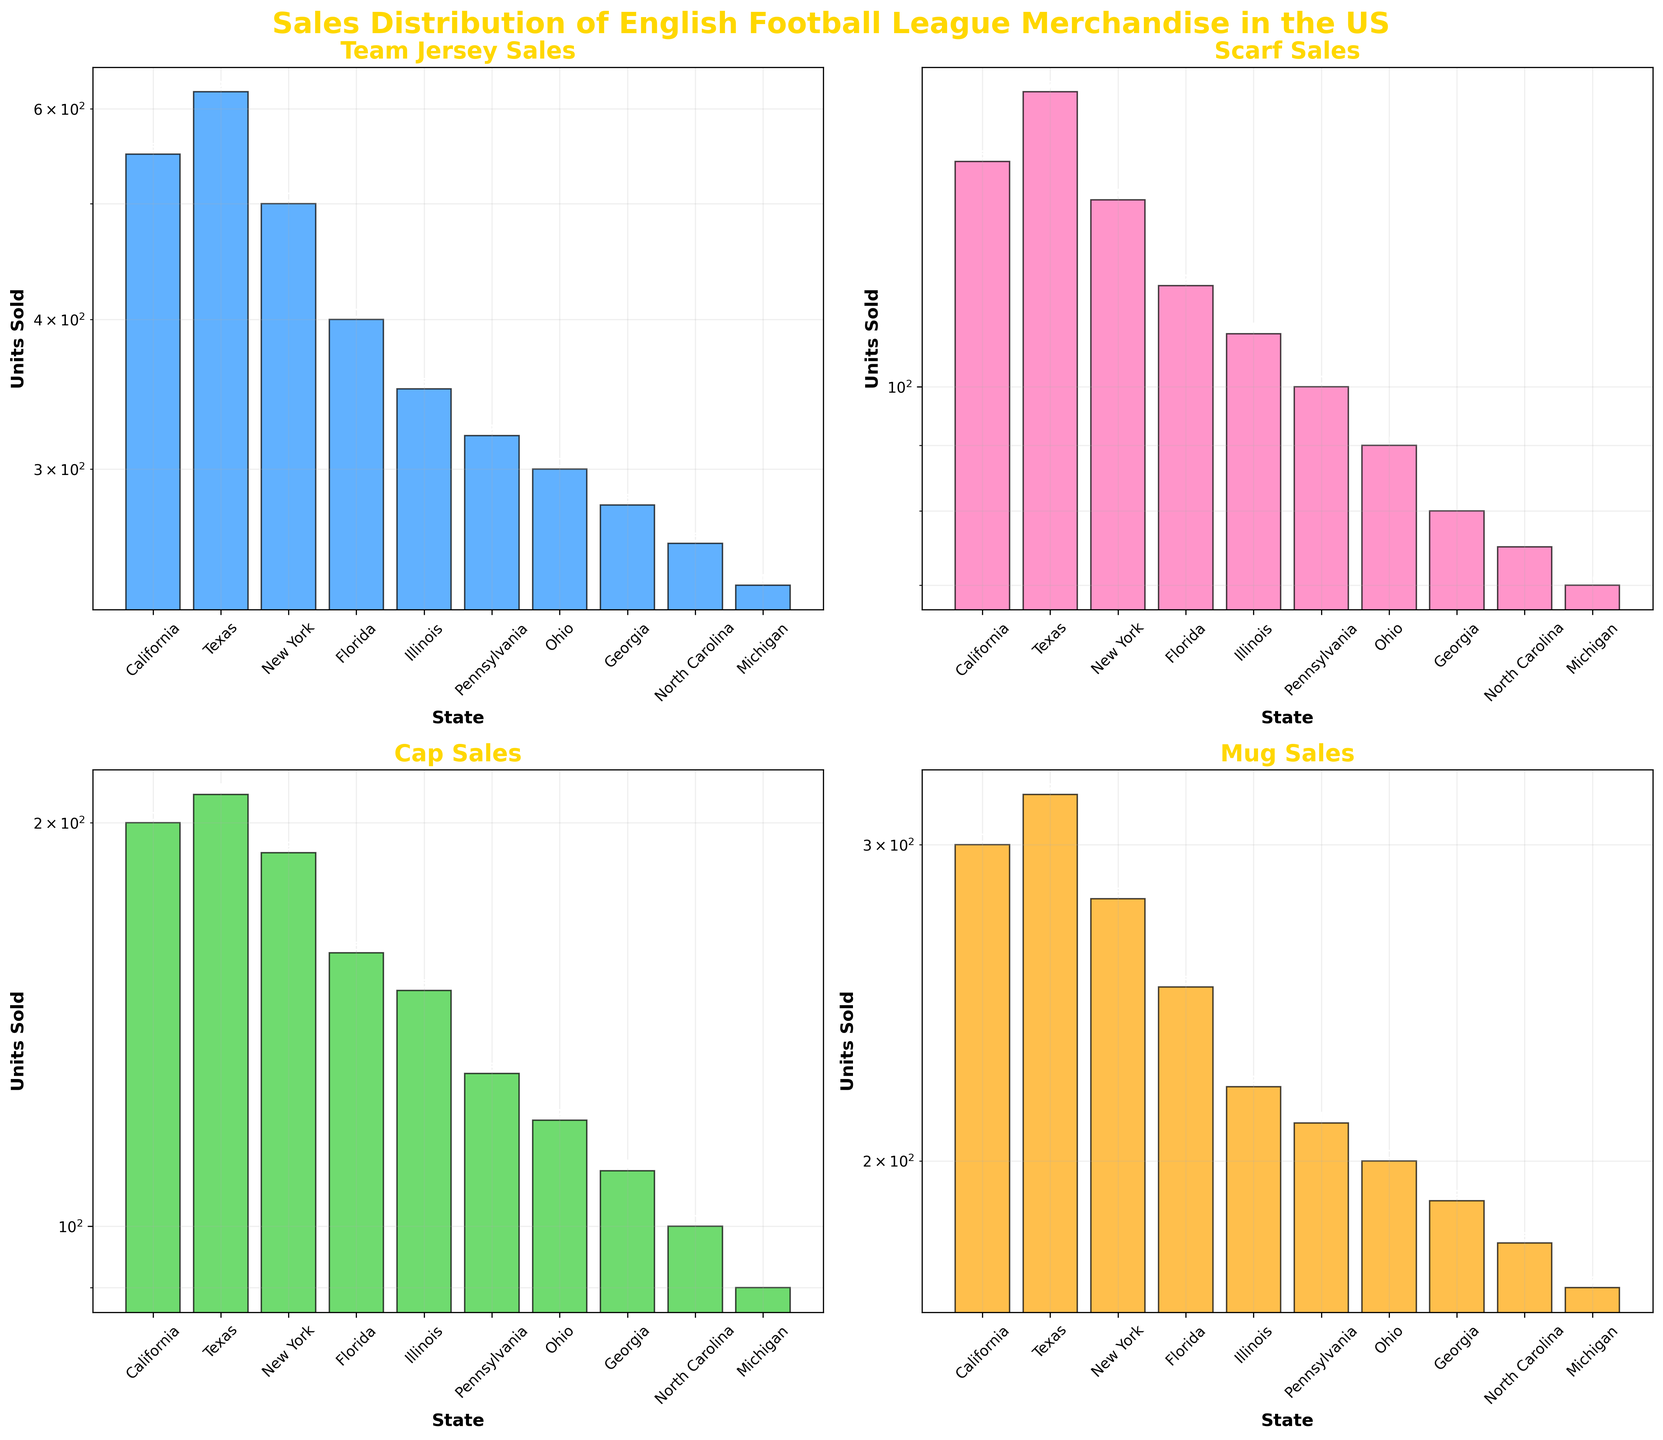What is the title of the figure? The title is displayed at the top of the figure. It reads "Sales Distribution of English Football League Merchandise in the US".
Answer: Sales Distribution of English Football League Merchandise in the US Which category of merchandise has the highest sales in Texas? In the Texas subplot, the highest bar is for "Team Jersey Sales", which is 620 units.
Answer: Team Jersey Sales How does the number of "Mug Sales" in California compare to that in Florida? In California, "Mug Sales" are at 300 units, while in Florida, they are at 250 units. 300 is greater than 250.
Answer: California has more Mug Sales What is the total number of "Scarf Sales" for the top three states by sales? The top three states by "Scarf Sales" are Texas (170), California (150), and New York (140). Adding these up: 170 + 150 + 140 = 460 units.
Answer: 460 units What is the ratio of "Cap Sales" to "Scarf Sales" in Illinois? In Illinois, "Cap Sales" are 150 units, and "Scarf Sales" are 110 units. The ratio is 150/110, which simplifies to approximately 1.36.
Answer: 1.36 Which state has the lowest "Team Jersey Sales"? By looking at the "Team Jersey Sales" bars across all subplots, Michigan has the lowest "Team Jersey Sales" at 240 units.
Answer: Michigan Are "Cap Sales" generally higher than "Scarf Sales" across the states? In each subplot, the height of the "Cap Sales" bar is consistently higher than the "Scarf Sales" bar across all states.
Answer: Yes, "Cap Sales" are generally higher Which category shows the most significant discrepancy between the highest and lowest selling states? "Team Jersey Sales" show the most significant discrepancy, with California at 550 units and Michigan at 240 units. The difference is 550 - 240 = 310 units.
Answer: Team Jersey Sales How many states have "Mug Sales" greater than 200 units? By checking each state's "Mug Sales" bar, California (300), Texas (320), New York (280), Florida (250), and Illinois (220) have "Mug Sales" greater than 200 units. There are 5 such states.
Answer: 5 states 